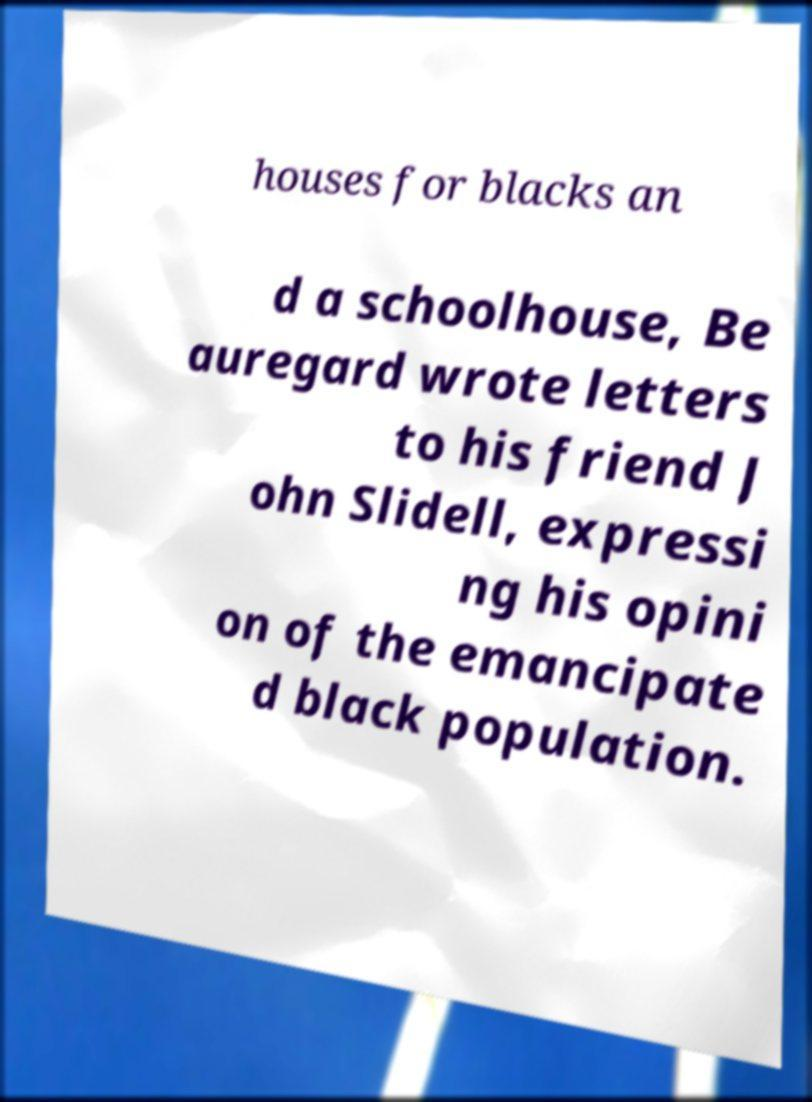There's text embedded in this image that I need extracted. Can you transcribe it verbatim? houses for blacks an d a schoolhouse, Be auregard wrote letters to his friend J ohn Slidell, expressi ng his opini on of the emancipate d black population. 